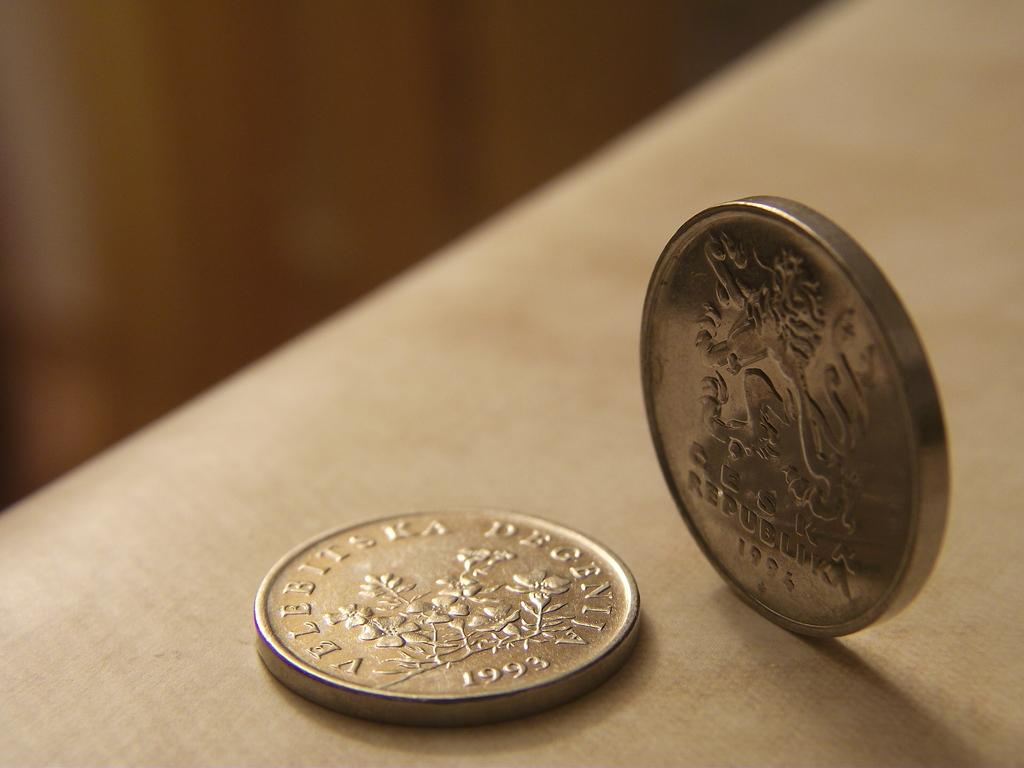<image>
Share a concise interpretation of the image provided. A silver coin with the year 1993 printed on it beside a standing coin with the year 1994 printed on it 